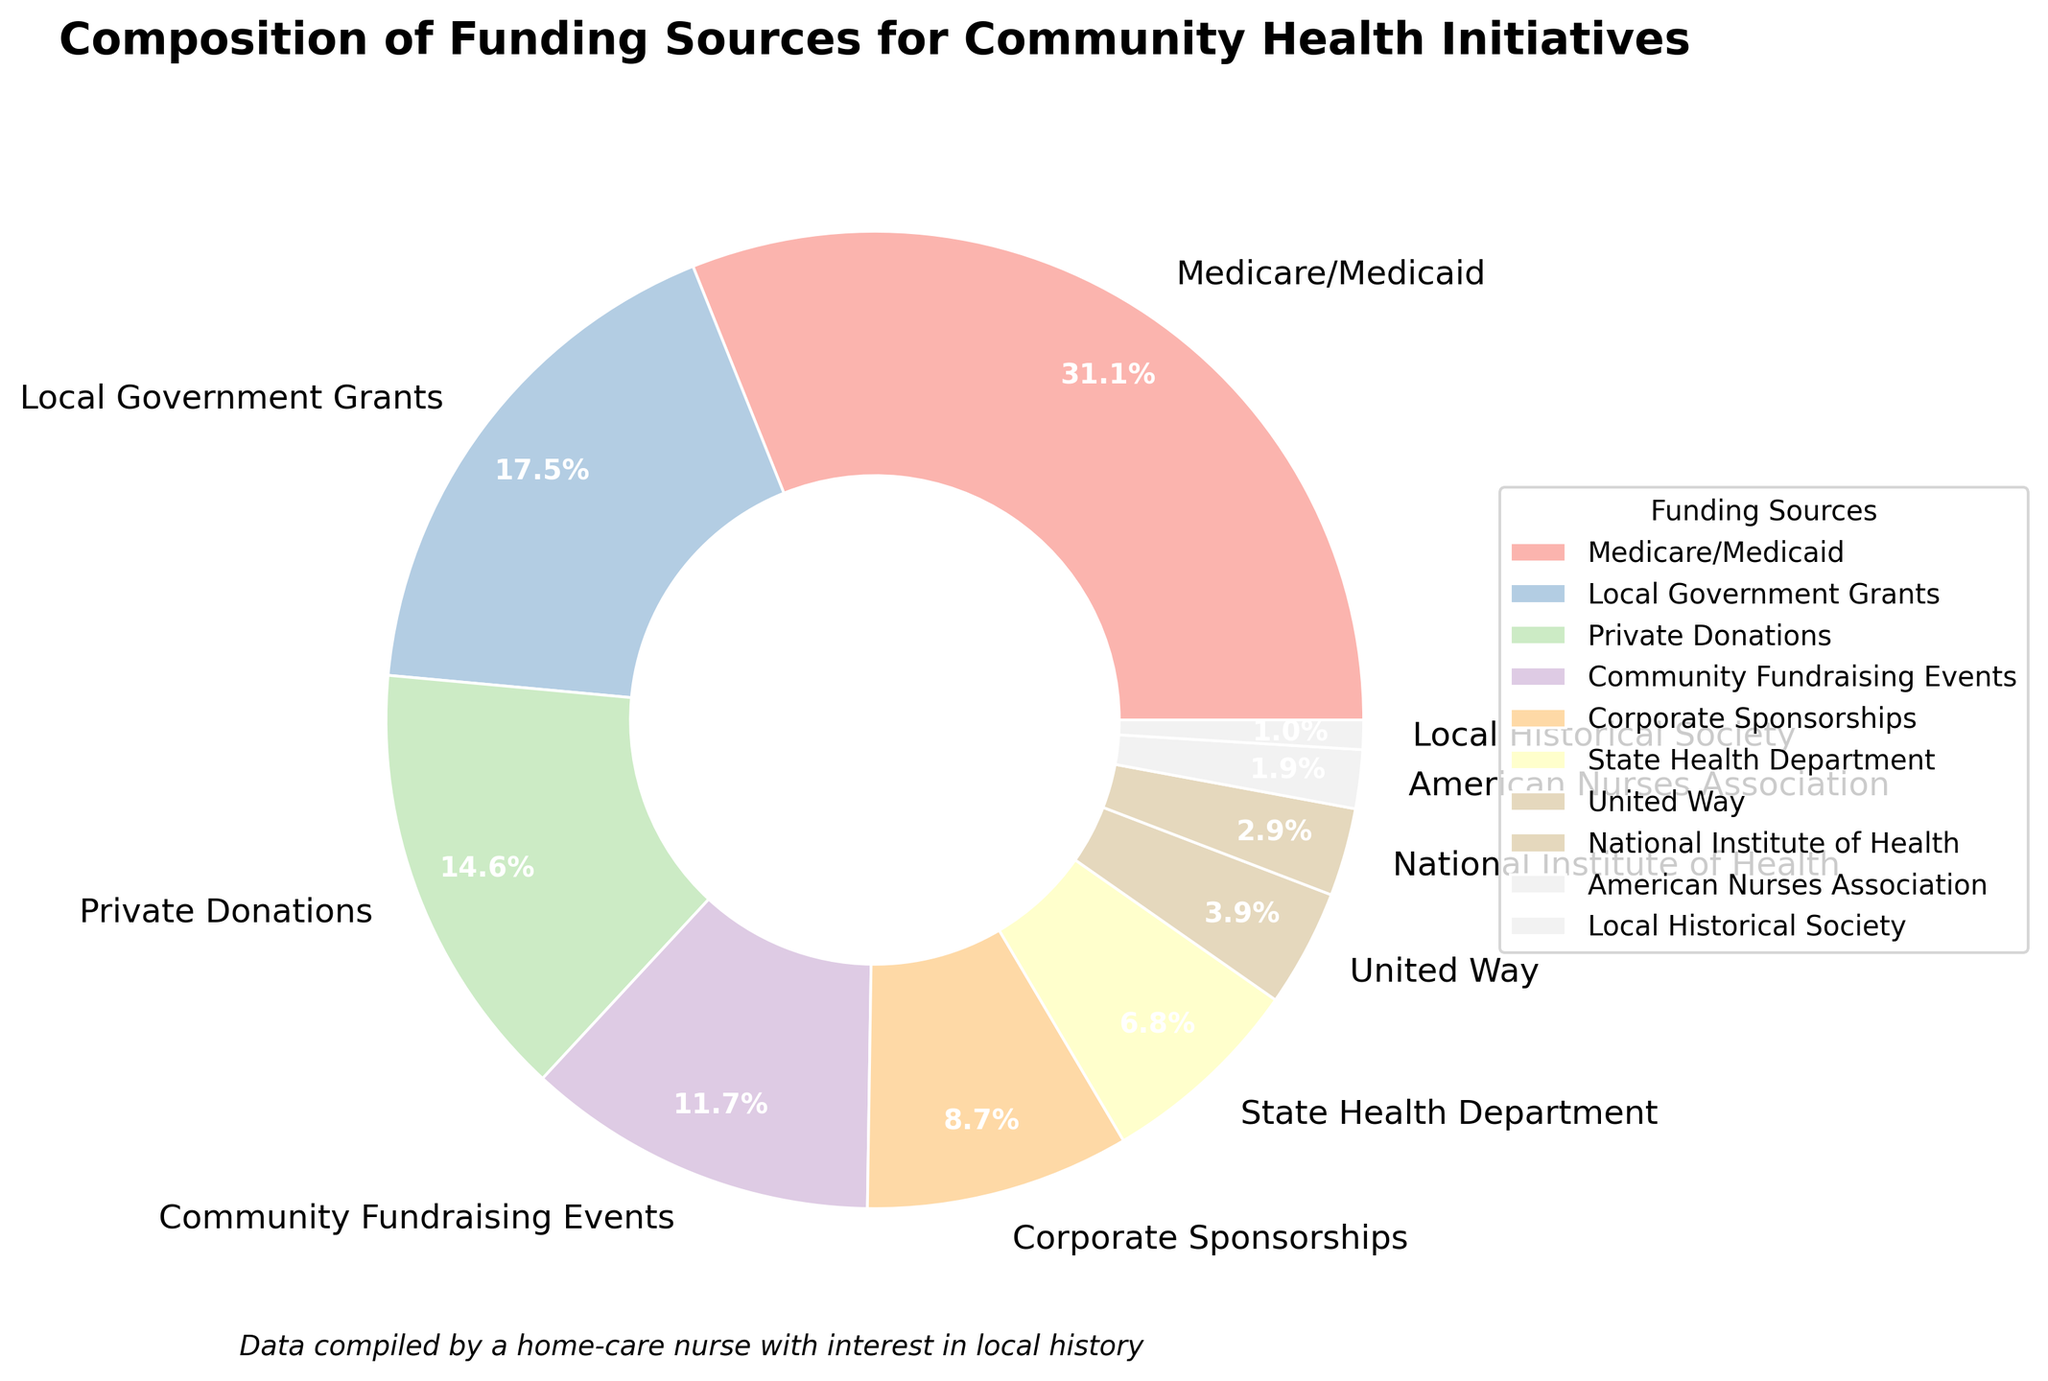Which funding source contributes the highest percentage? The funding sources and their respective percentages are shown in the pie chart. The largest portion is represented by "Medicare/Medicaid" with 32%.
Answer: Medicare/Medicaid What's the combined percentage of Local Government Grants and Private Donations? Local Government Grants have 18% and Private Donations have 15%. Adding them gives 18% + 15% = 33%.
Answer: 33% How much more does Medicare/Medicaid contribute compared to Corporate Sponsorships? Medicare/Medicaid contributes 32% while Corporate Sponsorships contribute 9%. The difference is 32% - 9% = 23%.
Answer: 23% Which funding sources contribute less than 10% each? The funding sources with less than 10% are highlighted in the pie chart: Corporate Sponsorships (9%), State Health Department (7%), United Way (4%), National Institute of Health (3%), American Nurses Association (2%), and Local Historical Society (1%).
Answer: Corporate Sponsorships, State Health Department, United Way, National Institute of Health, American Nurses Association, Local Historical Society Which segment is colored in the lightest shade? The pie chart sections are shaded differently, and the lightest shade is used for the Local Historical Society, which contributes 1%.
Answer: Local Historical Society How does the sum of percentages of Community Fundraising Events and United Way compare to that of Private Donations? Community Fundraising Events contribute 12% and United Way 4%. Their sum is 12% + 4% = 16%. Private Donations contribute 15%. So, 16% > 15%.
Answer: Community Fundraising Events and United Way combined are more than Private Donations What is the total percentage contributed by Local Government Grants, Corporate Sponsorships, and the State Health Department? Local Government Grants contribute 18%, Corporate Sponsorships 9%, and State Health Department 7%. The sum is 18% + 9% + 7% = 34%.
Answer: 34% Between Private Donations and Community Fundraising Events, which one has a higher percentage and by how much? Private Donations contribute 15% while Community Fundraising Events contribute 12%. The difference is 15% - 12% = 3%.
Answer: Private Donations by 3% Which funding source has the least percentage and what is it? The smallest segment in the pie chart represents the Local Historical Society with 1%.
Answer: Local Historical Society (1%) 